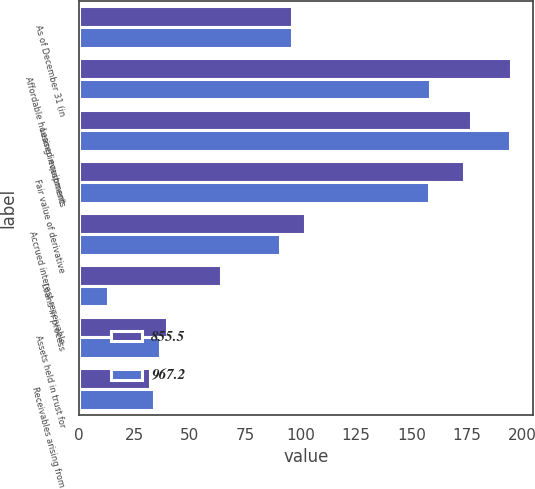Convert chart to OTSL. <chart><loc_0><loc_0><loc_500><loc_500><stacked_bar_chart><ecel><fcel>As of December 31 (in<fcel>Affordable housing investments<fcel>Leased equipment<fcel>Fair value of derivative<fcel>Accrued interest receivable<fcel>Loans in process<fcel>Assets held in trust for<fcel>Receivables arising from<nl><fcel>855.5<fcel>96.2<fcel>195.2<fcel>176.9<fcel>174<fcel>101.8<fcel>63.9<fcel>39.6<fcel>32<nl><fcel>967.2<fcel>96.2<fcel>158.4<fcel>194.4<fcel>158.2<fcel>90.6<fcel>13.1<fcel>36.5<fcel>33.7<nl></chart> 